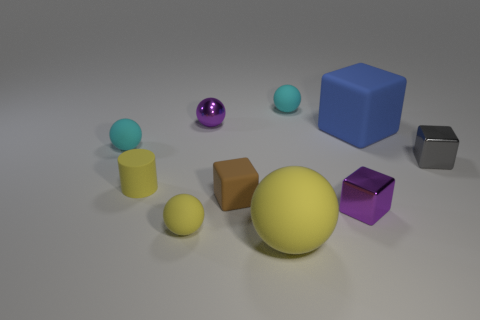What material is the tiny object that is the same color as the small metallic sphere?
Keep it short and to the point. Metal. Are there fewer small matte objects that are in front of the gray shiny block than shiny spheres in front of the big cube?
Your answer should be very brief. No. Do the tiny purple block and the small purple thing that is behind the tiny cylinder have the same material?
Your response must be concise. Yes. Are there more yellow matte spheres than cylinders?
Keep it short and to the point. Yes. There is a yellow matte thing that is to the right of the small sphere in front of the cyan ball that is on the left side of the brown cube; what is its shape?
Provide a short and direct response. Sphere. Do the cyan object that is in front of the metallic sphere and the purple cube behind the big yellow matte thing have the same material?
Keep it short and to the point. No. What shape is the small purple thing that is made of the same material as the purple cube?
Keep it short and to the point. Sphere. Is there any other thing of the same color as the large block?
Your response must be concise. No. What number of big brown shiny cylinders are there?
Your response must be concise. 0. What material is the purple cube behind the yellow sphere to the left of the big yellow object made of?
Your answer should be compact. Metal. 